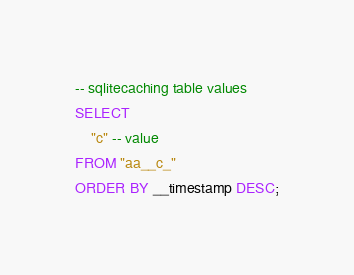<code> <loc_0><loc_0><loc_500><loc_500><_SQL_>-- sqlitecaching table values
SELECT
    "c" -- value
FROM "aa__c_"
ORDER BY __timestamp DESC;
</code> 